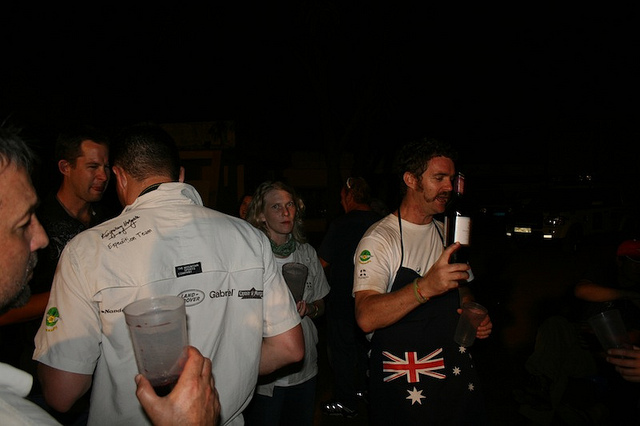<image>What are the men standing around? The men are likely standing around a bar or each other. However, I cannot say for certain without seeing the image. What are the men standing around? I don't know what the men are standing around. It can be each other or a bar. 